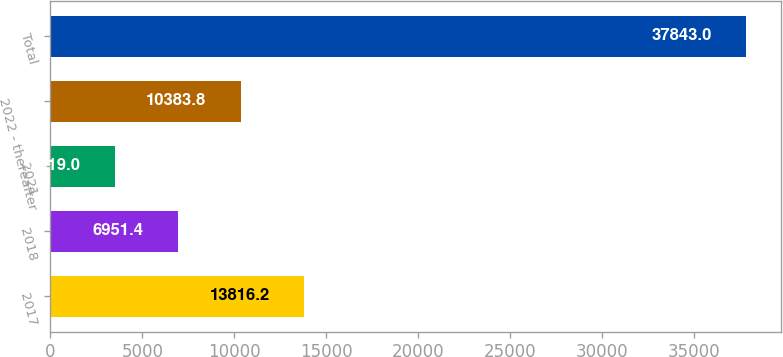Convert chart. <chart><loc_0><loc_0><loc_500><loc_500><bar_chart><fcel>2017<fcel>2018<fcel>2021<fcel>2022 - thereafter<fcel>Total<nl><fcel>13816.2<fcel>6951.4<fcel>3519<fcel>10383.8<fcel>37843<nl></chart> 